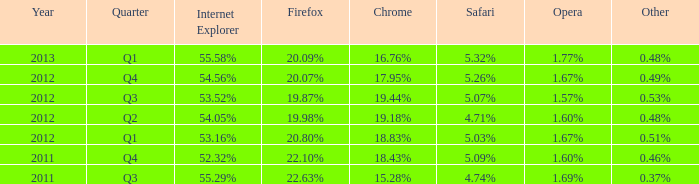Which web browser has 53.16%. 